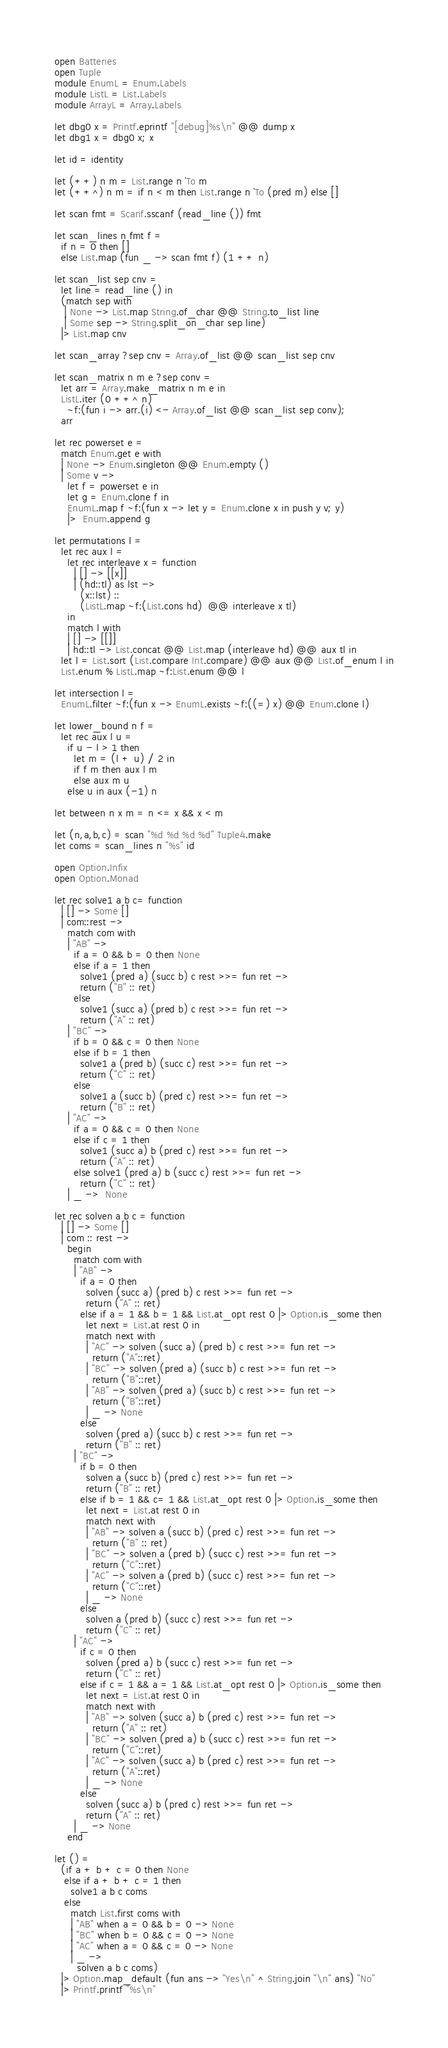Convert code to text. <code><loc_0><loc_0><loc_500><loc_500><_OCaml_>open Batteries
open Tuple
module EnumL = Enum.Labels
module ListL = List.Labels
module ArrayL = Array.Labels

let dbg0 x = Printf.eprintf "[debug]%s\n" @@ dump x
let dbg1 x = dbg0 x; x

let id = identity

let (++) n m = List.range n `To m
let (++^) n m = if n < m then List.range n `To (pred m) else []

let scan fmt = Scanf.sscanf (read_line ()) fmt

let scan_lines n fmt f =
  if n = 0 then []
  else List.map (fun _ -> scan fmt f) (1 ++ n)

let scan_list sep cnv =
  let line = read_line () in
  (match sep with
   | None -> List.map String.of_char @@ String.to_list line
   | Some sep -> String.split_on_char sep line)
  |> List.map cnv

let scan_array ?sep cnv = Array.of_list @@ scan_list sep cnv

let scan_matrix n m e ?sep conv =
  let arr = Array.make_matrix n m e in
  ListL.iter (0 ++^ n)
    ~f:(fun i -> arr.(i) <- Array.of_list @@ scan_list sep conv);
  arr

let rec powerset e =
  match Enum.get e with
  | None -> Enum.singleton @@ Enum.empty ()
  | Some v ->
    let f = powerset e in
    let g = Enum.clone f in
    EnumL.map f ~f:(fun x -> let y = Enum.clone x in push y v; y)
    |>  Enum.append g

let permutations l =
  let rec aux l =
    let rec interleave x = function
      | [] -> [[x]]
      | (hd::tl) as lst ->
        (x::lst) ::
        (ListL.map ~f:(List.cons hd)  @@ interleave x tl)
    in
    match l with
    | [] -> [[]]
    | hd::tl -> List.concat @@ List.map (interleave hd) @@ aux tl in
  let l = List.sort (List.compare Int.compare) @@ aux @@ List.of_enum l in
  List.enum % ListL.map ~f:List.enum @@ l

let intersection l =
  EnumL.filter ~f:(fun x -> EnumL.exists ~f:((=) x) @@ Enum.clone l)

let lower_bound n f =
  let rec aux l u =
    if u - l > 1 then
      let m = (l + u) / 2 in
      if f m then aux l m
      else aux m u
    else u in aux (-1) n

let between n x m = n <= x && x < m

let (n,a,b,c) = scan "%d %d %d %d" Tuple4.make
let coms = scan_lines n "%s" id

open Option.Infix
open Option.Monad

let rec solve1 a b c= function
  | [] -> Some []
  | com::rest ->
    match com with
    | "AB" ->
      if a = 0 && b = 0 then None
      else if a = 1 then
        solve1 (pred a) (succ b) c rest >>= fun ret ->
        return ("B" :: ret)
      else
        solve1 (succ a) (pred b) c rest >>= fun ret ->
        return ("A" :: ret)
    | "BC" ->
      if b = 0 && c = 0 then None
      else if b = 1 then
        solve1 a (pred b) (succ c) rest >>= fun ret ->
        return ("C" :: ret)
      else
        solve1 a (succ b) (pred c) rest >>= fun ret ->
        return ("B" :: ret)
    | "AC" ->
      if a = 0 && c = 0 then None
      else if c = 1 then
        solve1 (succ a) b (pred c) rest >>= fun ret ->
        return ("A" :: ret)
      else solve1 (pred a) b (succ c) rest >>= fun ret ->
        return ("C" :: ret)
    | _ ->  None

let rec solven a b c = function
  | [] -> Some []
  | com :: rest ->
    begin
      match com with
      | "AB" ->
        if a = 0 then
          solven (succ a) (pred b) c rest >>= fun ret ->
          return ("A" :: ret)
        else if a = 1 && b = 1 && List.at_opt rest 0 |> Option.is_some then
          let next = List.at rest 0 in
          match next with
          | "AC" -> solven (succ a) (pred b) c rest >>= fun ret ->
            return ("A"::ret)
          | "BC" -> solven (pred a) (succ b) c rest >>= fun ret ->
            return ("B"::ret)
          | "AB" -> solven (pred a) (succ b) c rest >>= fun ret ->
            return ("B"::ret)
          | _ -> None
        else
          solven (pred a) (succ b) c rest >>= fun ret ->
          return ("B" :: ret)
      | "BC" ->
        if b = 0 then
          solven a (succ b) (pred c) rest >>= fun ret ->
          return ("B" :: ret)
        else if b = 1 && c= 1 && List.at_opt rest 0 |> Option.is_some then
          let next = List.at rest 0 in
          match next with
          | "AB" -> solven a (succ b) (pred c) rest >>= fun ret ->
            return ("B" :: ret)
          | "BC" -> solven a (pred b) (succ c) rest >>= fun ret ->
            return ("C"::ret)
          | "AC" -> solven a (pred b) (succ c) rest >>= fun ret ->
            return ("C"::ret)
          | _ -> None
        else
          solven a (pred b) (succ c) rest >>= fun ret ->
          return ("C" :: ret)
      | "AC" ->
        if c = 0 then
          solven (pred a) b (succ c) rest >>= fun ret ->
          return ("C" :: ret)
        else if c = 1 && a = 1 && List.at_opt rest 0 |> Option.is_some then
          let next = List.at rest 0 in
          match next with
          | "AB" -> solven (succ a) b (pred c) rest >>= fun ret ->
            return ("A" :: ret)
          | "BC" -> solven (pred a) b (succ c) rest >>= fun ret ->
            return ("C"::ret)
          | "AC" -> solven (succ a) b (pred c) rest >>= fun ret ->
            return ("A"::ret)
          | _ -> None
        else
          solven (succ a) b (pred c) rest >>= fun ret ->
          return ("A" :: ret)
      | _ -> None
    end

let () =
  (if a + b + c = 0 then None
   else if a + b + c = 1 then
     solve1 a b c coms
   else
     match List.first coms with
     | "AB" when a = 0 && b = 0 -> None
     | "BC" when b = 0 && c = 0 -> None
     | "AC" when a = 0 && c = 0 -> None
     | _ ->
       solven a b c coms)
  |> Option.map_default (fun ans -> "Yes\n" ^ String.join "\n" ans) "No"
  |> Printf.printf "%s\n"
</code> 